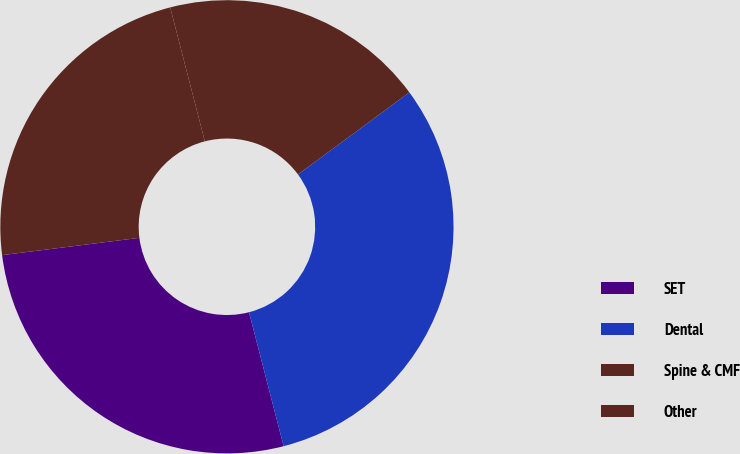Convert chart. <chart><loc_0><loc_0><loc_500><loc_500><pie_chart><fcel>SET<fcel>Dental<fcel>Spine & CMF<fcel>Other<nl><fcel>27.03%<fcel>31.08%<fcel>18.92%<fcel>22.97%<nl></chart> 